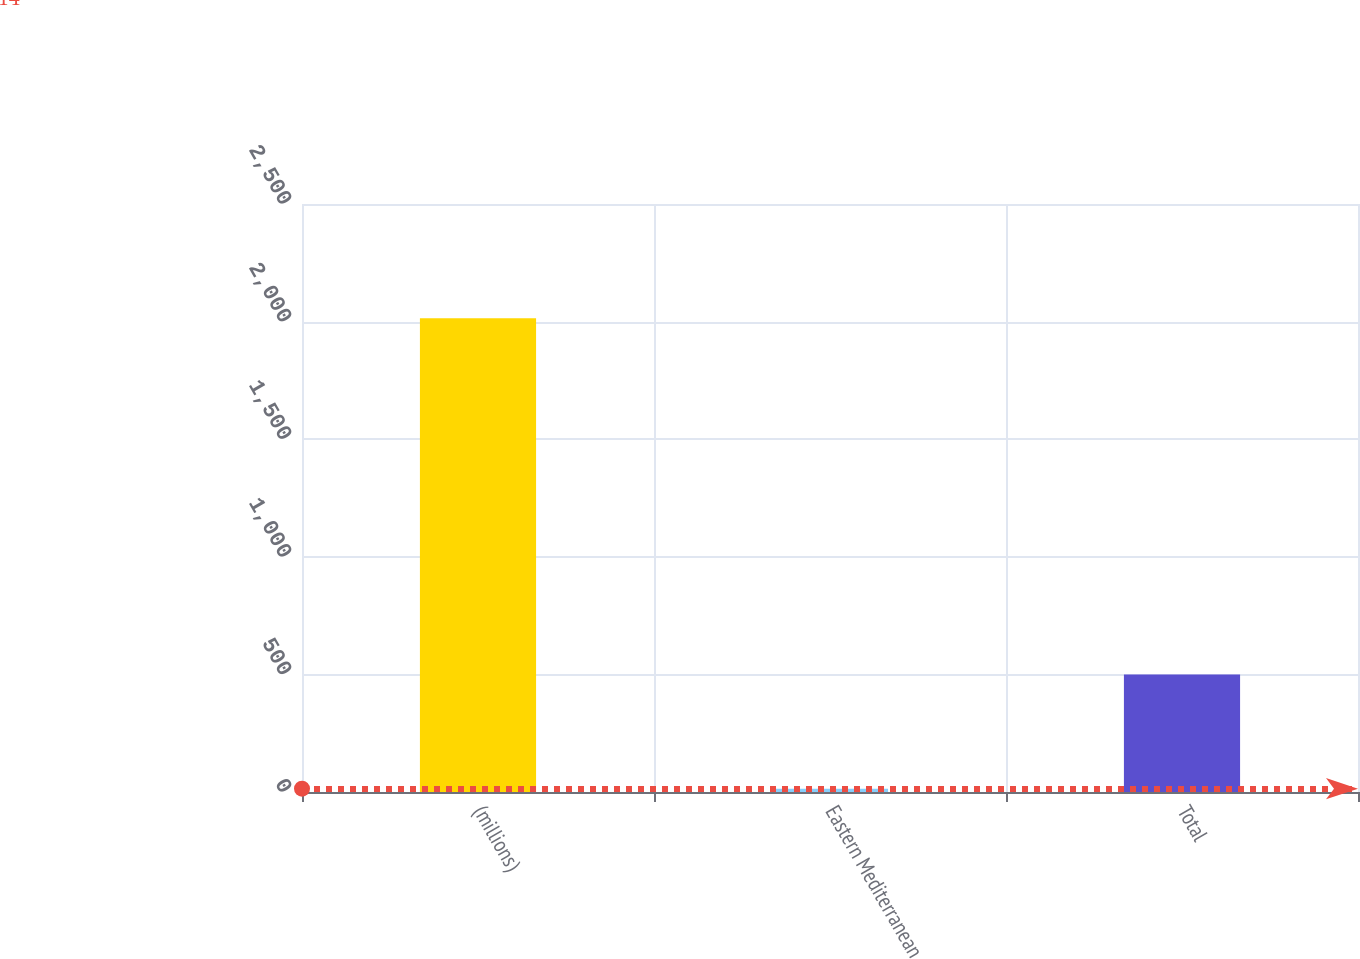Convert chart to OTSL. <chart><loc_0><loc_0><loc_500><loc_500><bar_chart><fcel>(millions)<fcel>Eastern Mediterranean<fcel>Total<nl><fcel>2014<fcel>14<fcel>500<nl></chart> 